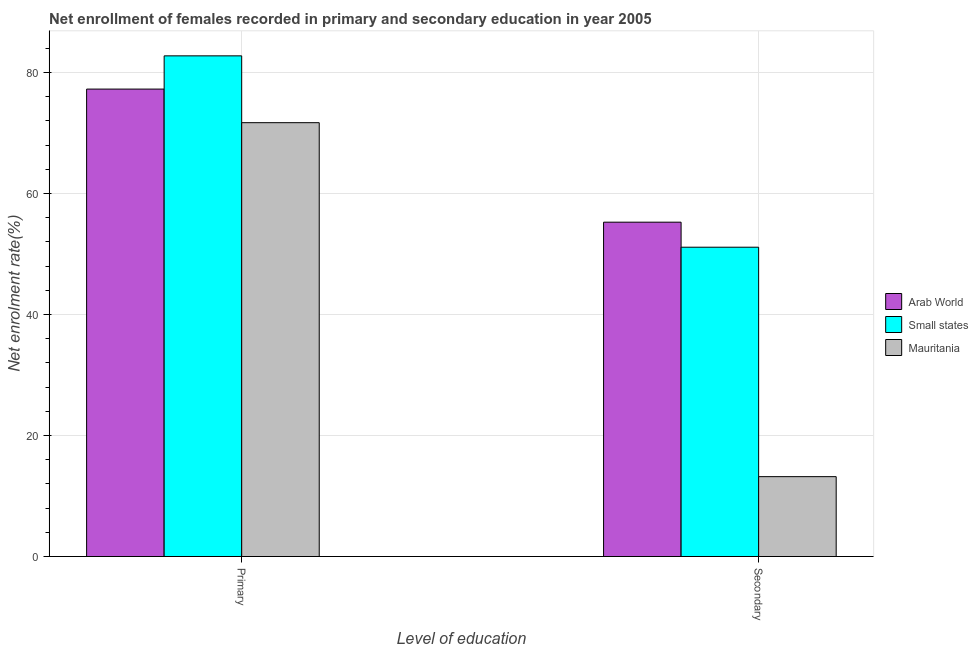How many different coloured bars are there?
Make the answer very short. 3. What is the label of the 2nd group of bars from the left?
Offer a terse response. Secondary. What is the enrollment rate in secondary education in Mauritania?
Your answer should be compact. 13.2. Across all countries, what is the maximum enrollment rate in primary education?
Make the answer very short. 82.73. Across all countries, what is the minimum enrollment rate in secondary education?
Offer a very short reply. 13.2. In which country was the enrollment rate in primary education maximum?
Ensure brevity in your answer.  Small states. In which country was the enrollment rate in primary education minimum?
Keep it short and to the point. Mauritania. What is the total enrollment rate in primary education in the graph?
Your answer should be compact. 231.66. What is the difference between the enrollment rate in primary education in Arab World and that in Small states?
Ensure brevity in your answer.  -5.49. What is the difference between the enrollment rate in primary education in Arab World and the enrollment rate in secondary education in Small states?
Offer a terse response. 26.13. What is the average enrollment rate in primary education per country?
Provide a short and direct response. 77.22. What is the difference between the enrollment rate in primary education and enrollment rate in secondary education in Small states?
Provide a succinct answer. 31.62. In how many countries, is the enrollment rate in primary education greater than 20 %?
Offer a very short reply. 3. What is the ratio of the enrollment rate in secondary education in Small states to that in Mauritania?
Give a very brief answer. 3.87. What does the 1st bar from the left in Primary represents?
Ensure brevity in your answer.  Arab World. What does the 3rd bar from the right in Primary represents?
Your answer should be very brief. Arab World. How many bars are there?
Provide a short and direct response. 6. Are all the bars in the graph horizontal?
Offer a very short reply. No. Where does the legend appear in the graph?
Make the answer very short. Center right. How many legend labels are there?
Make the answer very short. 3. How are the legend labels stacked?
Give a very brief answer. Vertical. What is the title of the graph?
Your answer should be compact. Net enrollment of females recorded in primary and secondary education in year 2005. Does "Honduras" appear as one of the legend labels in the graph?
Ensure brevity in your answer.  No. What is the label or title of the X-axis?
Ensure brevity in your answer.  Level of education. What is the label or title of the Y-axis?
Your answer should be very brief. Net enrolment rate(%). What is the Net enrolment rate(%) of Arab World in Primary?
Ensure brevity in your answer.  77.24. What is the Net enrolment rate(%) of Small states in Primary?
Keep it short and to the point. 82.73. What is the Net enrolment rate(%) in Mauritania in Primary?
Provide a short and direct response. 71.69. What is the Net enrolment rate(%) of Arab World in Secondary?
Offer a terse response. 55.25. What is the Net enrolment rate(%) in Small states in Secondary?
Your answer should be very brief. 51.11. What is the Net enrolment rate(%) of Mauritania in Secondary?
Make the answer very short. 13.2. Across all Level of education, what is the maximum Net enrolment rate(%) of Arab World?
Ensure brevity in your answer.  77.24. Across all Level of education, what is the maximum Net enrolment rate(%) of Small states?
Offer a terse response. 82.73. Across all Level of education, what is the maximum Net enrolment rate(%) in Mauritania?
Offer a terse response. 71.69. Across all Level of education, what is the minimum Net enrolment rate(%) in Arab World?
Your answer should be very brief. 55.25. Across all Level of education, what is the minimum Net enrolment rate(%) of Small states?
Offer a terse response. 51.11. Across all Level of education, what is the minimum Net enrolment rate(%) of Mauritania?
Provide a short and direct response. 13.2. What is the total Net enrolment rate(%) of Arab World in the graph?
Provide a succinct answer. 132.49. What is the total Net enrolment rate(%) of Small states in the graph?
Provide a short and direct response. 133.84. What is the total Net enrolment rate(%) of Mauritania in the graph?
Your answer should be very brief. 84.89. What is the difference between the Net enrolment rate(%) of Arab World in Primary and that in Secondary?
Your answer should be compact. 21.99. What is the difference between the Net enrolment rate(%) in Small states in Primary and that in Secondary?
Your answer should be compact. 31.62. What is the difference between the Net enrolment rate(%) of Mauritania in Primary and that in Secondary?
Offer a very short reply. 58.49. What is the difference between the Net enrolment rate(%) in Arab World in Primary and the Net enrolment rate(%) in Small states in Secondary?
Ensure brevity in your answer.  26.13. What is the difference between the Net enrolment rate(%) in Arab World in Primary and the Net enrolment rate(%) in Mauritania in Secondary?
Your response must be concise. 64.04. What is the difference between the Net enrolment rate(%) in Small states in Primary and the Net enrolment rate(%) in Mauritania in Secondary?
Your response must be concise. 69.53. What is the average Net enrolment rate(%) of Arab World per Level of education?
Offer a very short reply. 66.24. What is the average Net enrolment rate(%) of Small states per Level of education?
Offer a very short reply. 66.92. What is the average Net enrolment rate(%) in Mauritania per Level of education?
Make the answer very short. 42.44. What is the difference between the Net enrolment rate(%) in Arab World and Net enrolment rate(%) in Small states in Primary?
Make the answer very short. -5.49. What is the difference between the Net enrolment rate(%) in Arab World and Net enrolment rate(%) in Mauritania in Primary?
Make the answer very short. 5.55. What is the difference between the Net enrolment rate(%) of Small states and Net enrolment rate(%) of Mauritania in Primary?
Provide a short and direct response. 11.04. What is the difference between the Net enrolment rate(%) in Arab World and Net enrolment rate(%) in Small states in Secondary?
Your answer should be compact. 4.13. What is the difference between the Net enrolment rate(%) in Arab World and Net enrolment rate(%) in Mauritania in Secondary?
Your answer should be very brief. 42.05. What is the difference between the Net enrolment rate(%) in Small states and Net enrolment rate(%) in Mauritania in Secondary?
Your response must be concise. 37.91. What is the ratio of the Net enrolment rate(%) of Arab World in Primary to that in Secondary?
Ensure brevity in your answer.  1.4. What is the ratio of the Net enrolment rate(%) in Small states in Primary to that in Secondary?
Give a very brief answer. 1.62. What is the ratio of the Net enrolment rate(%) in Mauritania in Primary to that in Secondary?
Offer a terse response. 5.43. What is the difference between the highest and the second highest Net enrolment rate(%) in Arab World?
Your answer should be compact. 21.99. What is the difference between the highest and the second highest Net enrolment rate(%) of Small states?
Your answer should be very brief. 31.62. What is the difference between the highest and the second highest Net enrolment rate(%) of Mauritania?
Your answer should be compact. 58.49. What is the difference between the highest and the lowest Net enrolment rate(%) of Arab World?
Your response must be concise. 21.99. What is the difference between the highest and the lowest Net enrolment rate(%) of Small states?
Your answer should be compact. 31.62. What is the difference between the highest and the lowest Net enrolment rate(%) in Mauritania?
Give a very brief answer. 58.49. 